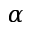Convert formula to latex. <formula><loc_0><loc_0><loc_500><loc_500>\alpha</formula> 